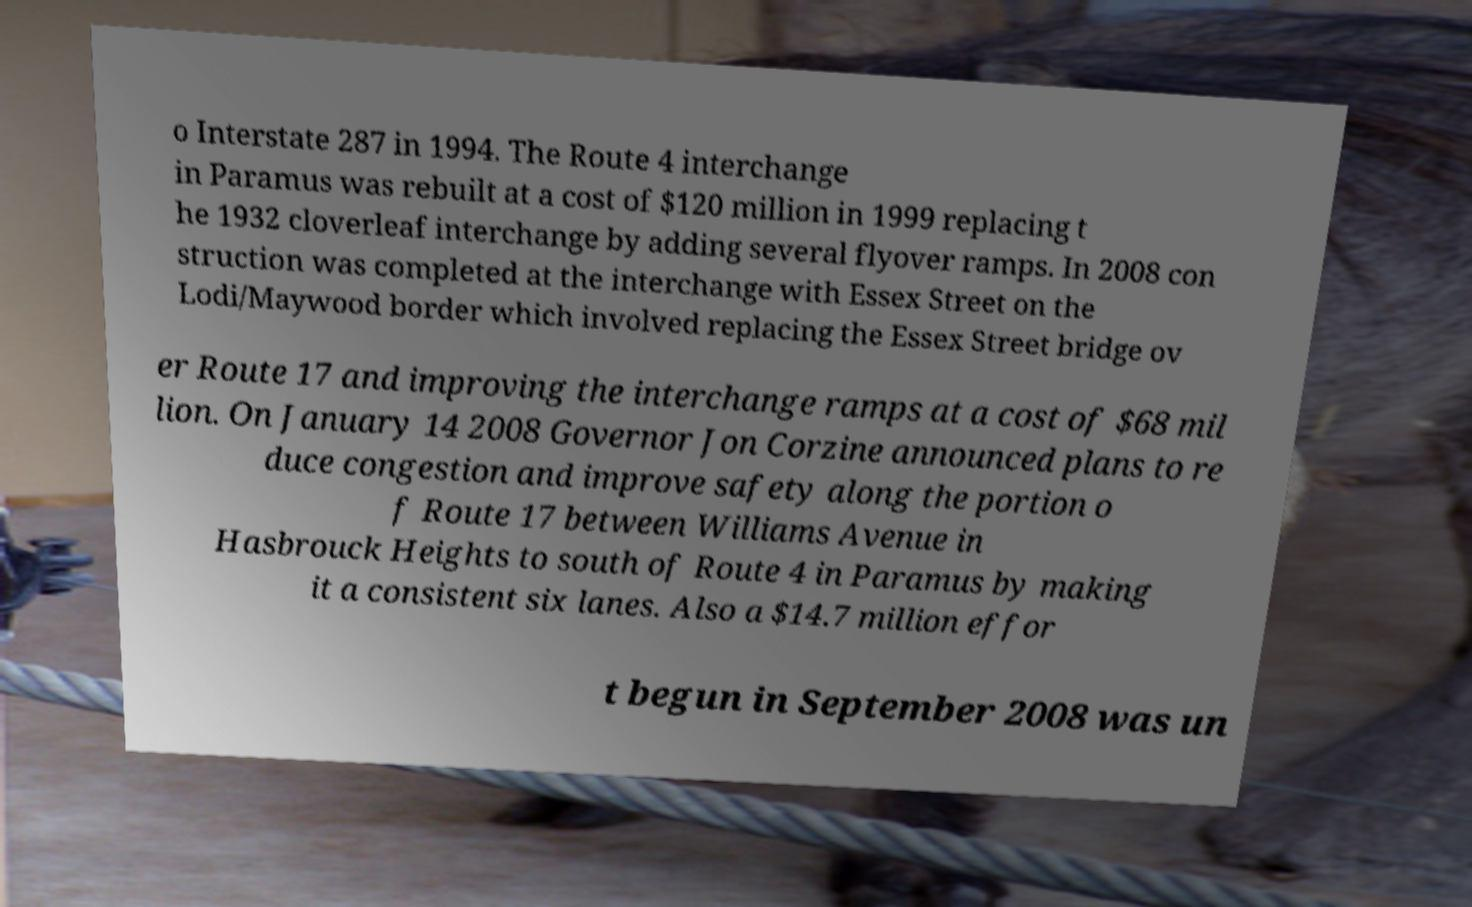Could you extract and type out the text from this image? o Interstate 287 in 1994. The Route 4 interchange in Paramus was rebuilt at a cost of $120 million in 1999 replacing t he 1932 cloverleaf interchange by adding several flyover ramps. In 2008 con struction was completed at the interchange with Essex Street on the Lodi/Maywood border which involved replacing the Essex Street bridge ov er Route 17 and improving the interchange ramps at a cost of $68 mil lion. On January 14 2008 Governor Jon Corzine announced plans to re duce congestion and improve safety along the portion o f Route 17 between Williams Avenue in Hasbrouck Heights to south of Route 4 in Paramus by making it a consistent six lanes. Also a $14.7 million effor t begun in September 2008 was un 